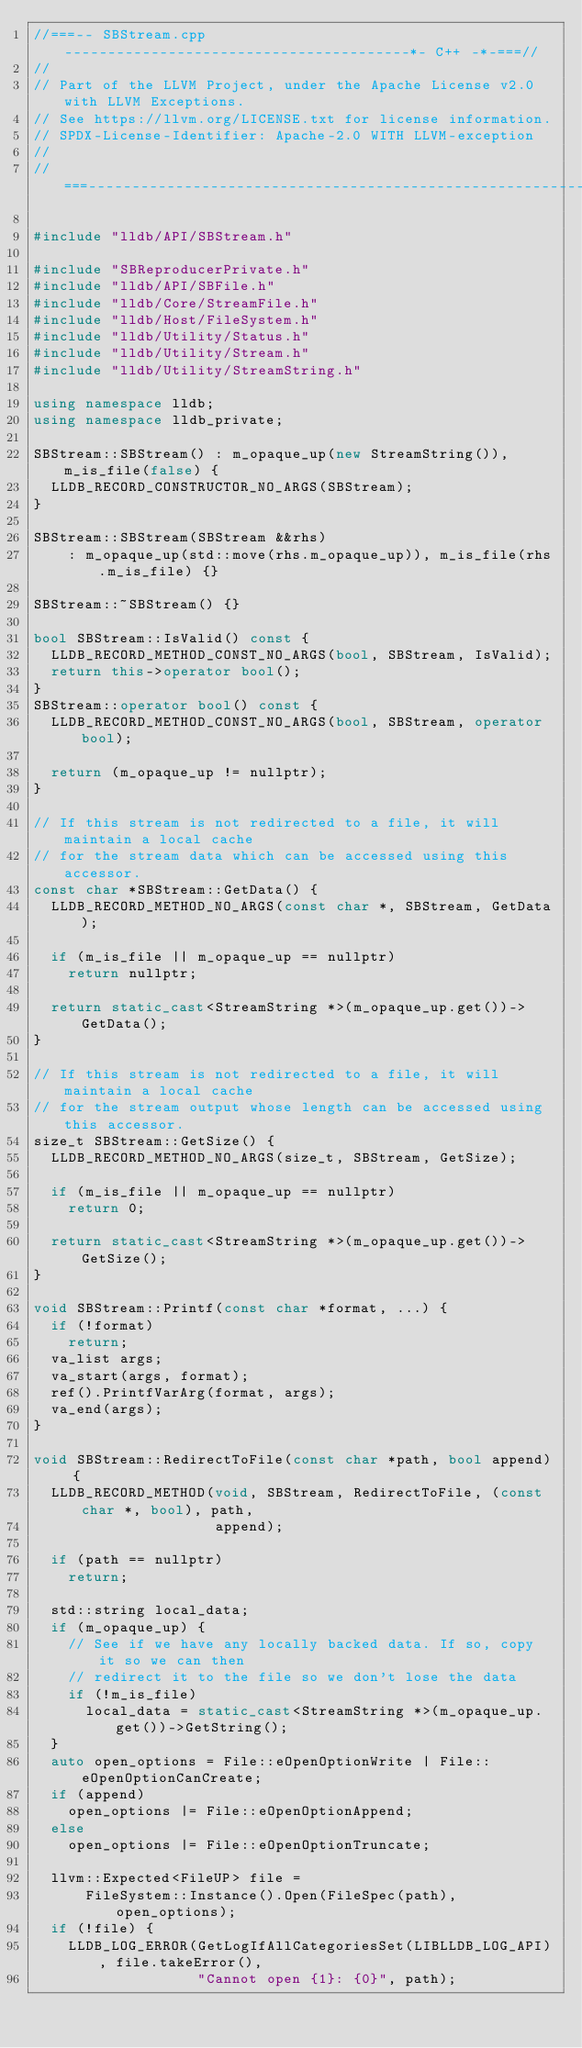<code> <loc_0><loc_0><loc_500><loc_500><_C++_>//===-- SBStream.cpp ----------------------------------------*- C++ -*-===//
//
// Part of the LLVM Project, under the Apache License v2.0 with LLVM Exceptions.
// See https://llvm.org/LICENSE.txt for license information.
// SPDX-License-Identifier: Apache-2.0 WITH LLVM-exception
//
//===----------------------------------------------------------------------===//

#include "lldb/API/SBStream.h"

#include "SBReproducerPrivate.h"
#include "lldb/API/SBFile.h"
#include "lldb/Core/StreamFile.h"
#include "lldb/Host/FileSystem.h"
#include "lldb/Utility/Status.h"
#include "lldb/Utility/Stream.h"
#include "lldb/Utility/StreamString.h"

using namespace lldb;
using namespace lldb_private;

SBStream::SBStream() : m_opaque_up(new StreamString()), m_is_file(false) {
  LLDB_RECORD_CONSTRUCTOR_NO_ARGS(SBStream);
}

SBStream::SBStream(SBStream &&rhs)
    : m_opaque_up(std::move(rhs.m_opaque_up)), m_is_file(rhs.m_is_file) {}

SBStream::~SBStream() {}

bool SBStream::IsValid() const {
  LLDB_RECORD_METHOD_CONST_NO_ARGS(bool, SBStream, IsValid);
  return this->operator bool();
}
SBStream::operator bool() const {
  LLDB_RECORD_METHOD_CONST_NO_ARGS(bool, SBStream, operator bool);

  return (m_opaque_up != nullptr);
}

// If this stream is not redirected to a file, it will maintain a local cache
// for the stream data which can be accessed using this accessor.
const char *SBStream::GetData() {
  LLDB_RECORD_METHOD_NO_ARGS(const char *, SBStream, GetData);

  if (m_is_file || m_opaque_up == nullptr)
    return nullptr;

  return static_cast<StreamString *>(m_opaque_up.get())->GetData();
}

// If this stream is not redirected to a file, it will maintain a local cache
// for the stream output whose length can be accessed using this accessor.
size_t SBStream::GetSize() {
  LLDB_RECORD_METHOD_NO_ARGS(size_t, SBStream, GetSize);

  if (m_is_file || m_opaque_up == nullptr)
    return 0;

  return static_cast<StreamString *>(m_opaque_up.get())->GetSize();
}

void SBStream::Printf(const char *format, ...) {
  if (!format)
    return;
  va_list args;
  va_start(args, format);
  ref().PrintfVarArg(format, args);
  va_end(args);
}

void SBStream::RedirectToFile(const char *path, bool append) {
  LLDB_RECORD_METHOD(void, SBStream, RedirectToFile, (const char *, bool), path,
                     append);

  if (path == nullptr)
    return;

  std::string local_data;
  if (m_opaque_up) {
    // See if we have any locally backed data. If so, copy it so we can then
    // redirect it to the file so we don't lose the data
    if (!m_is_file)
      local_data = static_cast<StreamString *>(m_opaque_up.get())->GetString();
  }
  auto open_options = File::eOpenOptionWrite | File::eOpenOptionCanCreate;
  if (append)
    open_options |= File::eOpenOptionAppend;
  else
    open_options |= File::eOpenOptionTruncate;

  llvm::Expected<FileUP> file =
      FileSystem::Instance().Open(FileSpec(path), open_options);
  if (!file) {
    LLDB_LOG_ERROR(GetLogIfAllCategoriesSet(LIBLLDB_LOG_API), file.takeError(),
                   "Cannot open {1}: {0}", path);</code> 